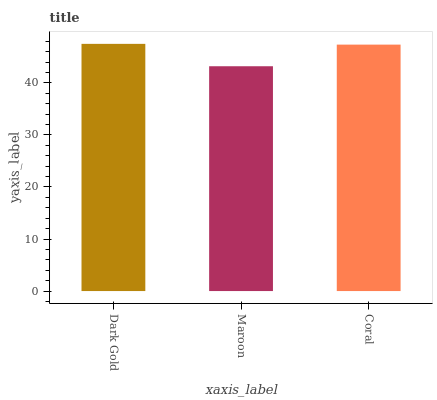Is Coral the minimum?
Answer yes or no. No. Is Coral the maximum?
Answer yes or no. No. Is Coral greater than Maroon?
Answer yes or no. Yes. Is Maroon less than Coral?
Answer yes or no. Yes. Is Maroon greater than Coral?
Answer yes or no. No. Is Coral less than Maroon?
Answer yes or no. No. Is Coral the high median?
Answer yes or no. Yes. Is Coral the low median?
Answer yes or no. Yes. Is Dark Gold the high median?
Answer yes or no. No. Is Maroon the low median?
Answer yes or no. No. 